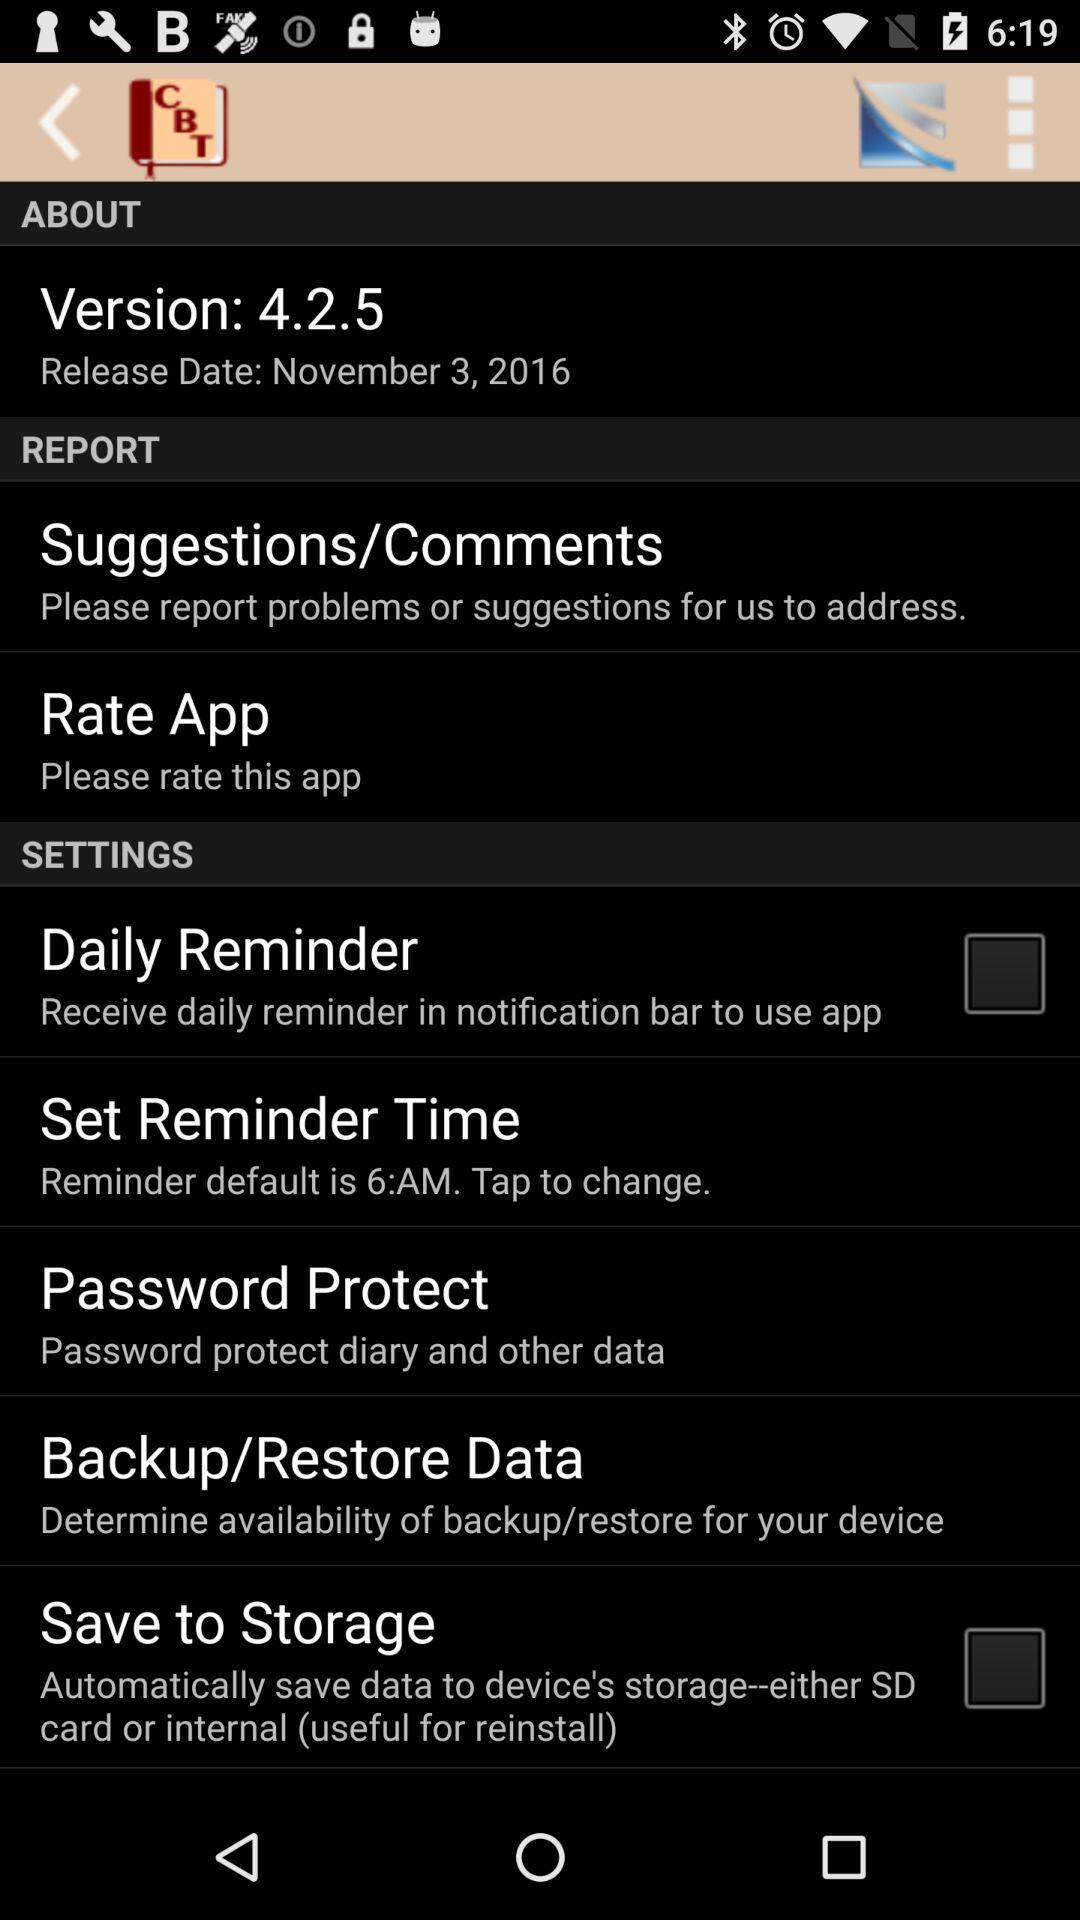What is the status of "Daily Reminder"? The status is "off". 